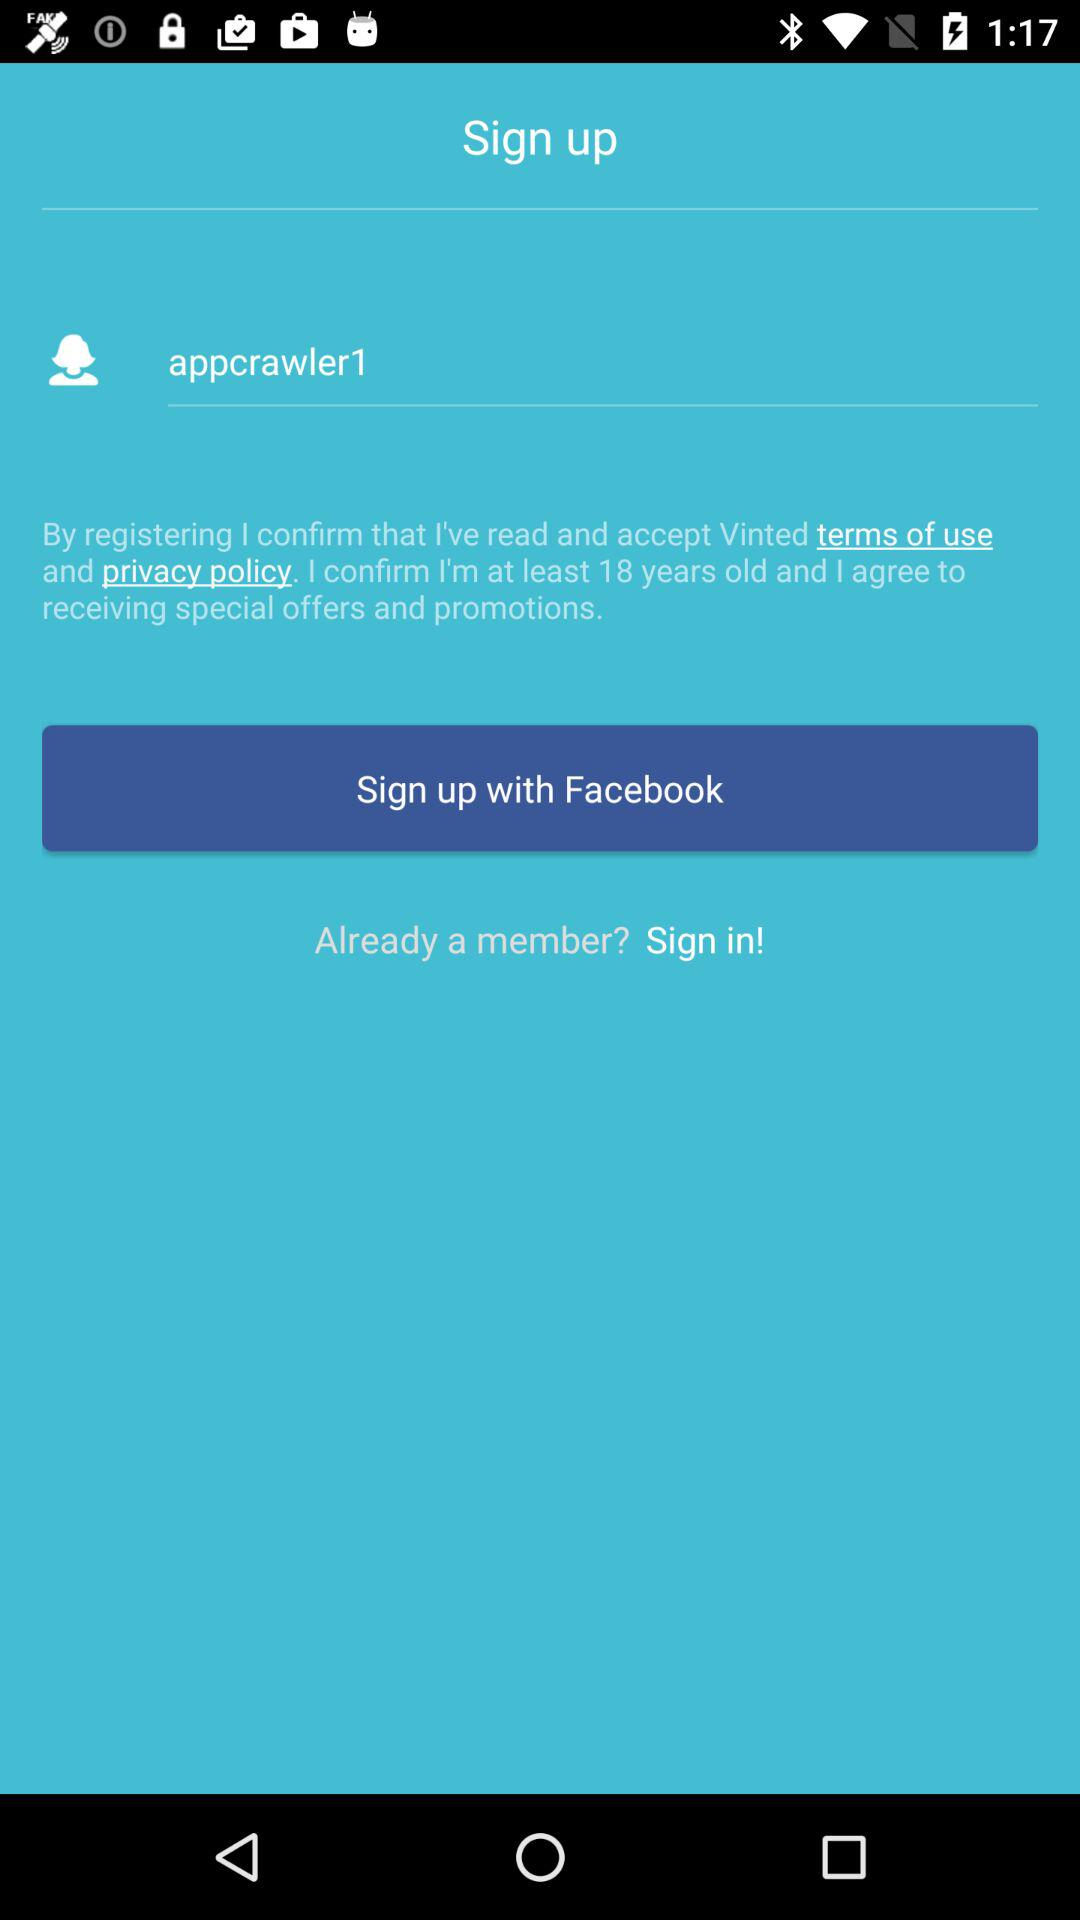Which age users are eligible to sign up? Users who are at least 18 years old are eligible to sign up. 